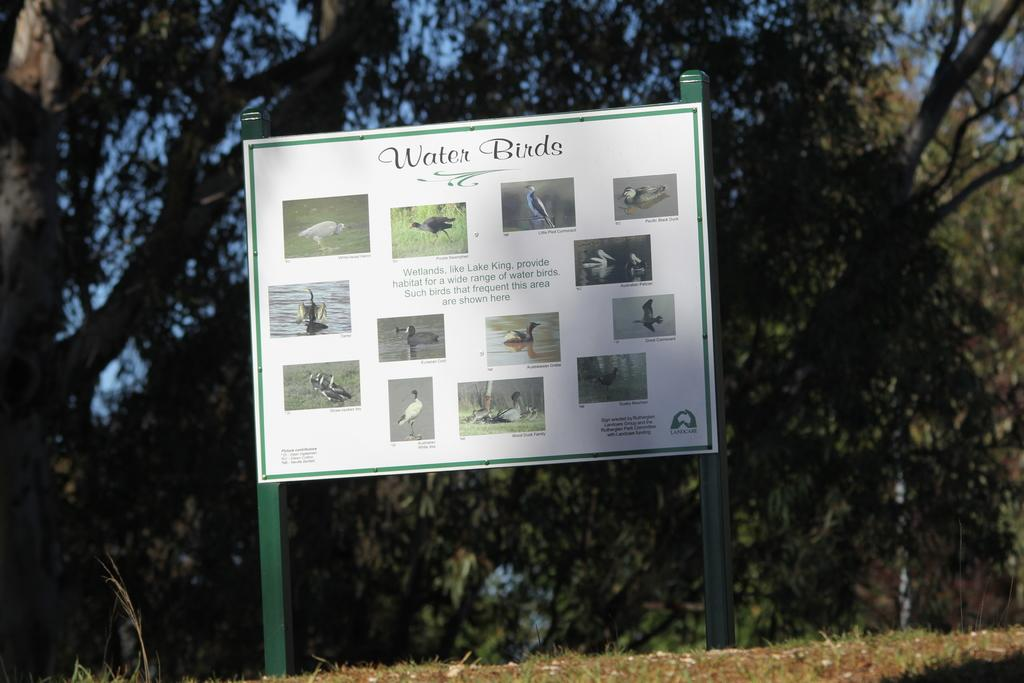What is the main object in the picture? There is a board in the picture. What can be seen on the board? The board contains bird images and text. What is visible in the background of the picture? There are trees visible in the background of the picture. What type of caption is written under the bird images on the board? There is no caption written under the bird images on the board; the text on the board is not specified in the facts provided. 